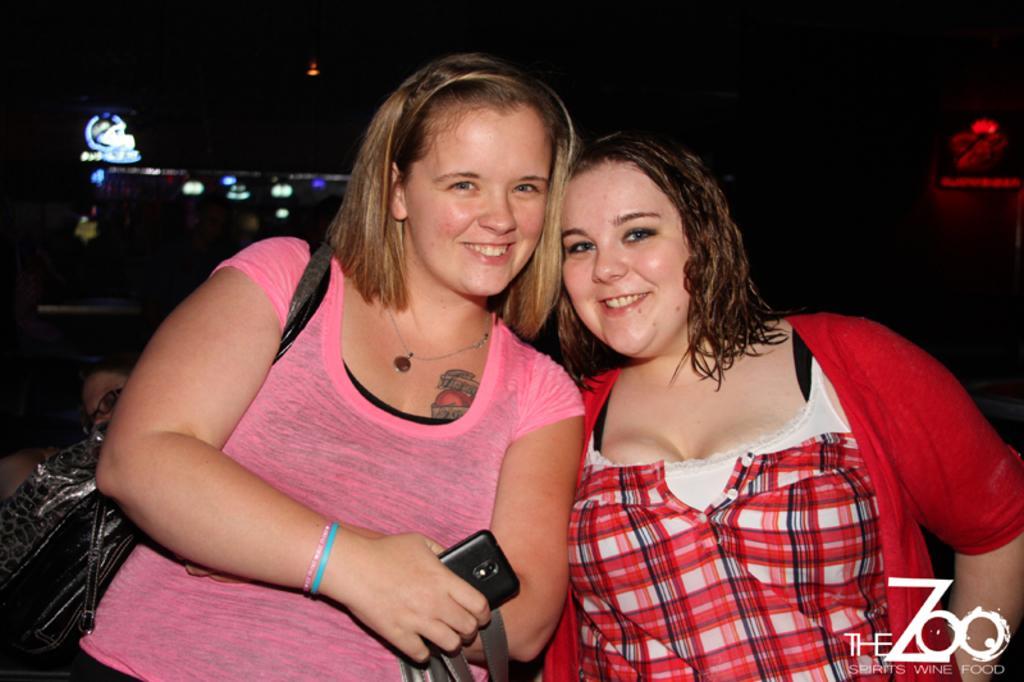In one or two sentences, can you explain what this image depicts? In this image we can see some people standing. One woman is wearing a bag and holding a mobile in her hand. In the background, we can see some lights. 